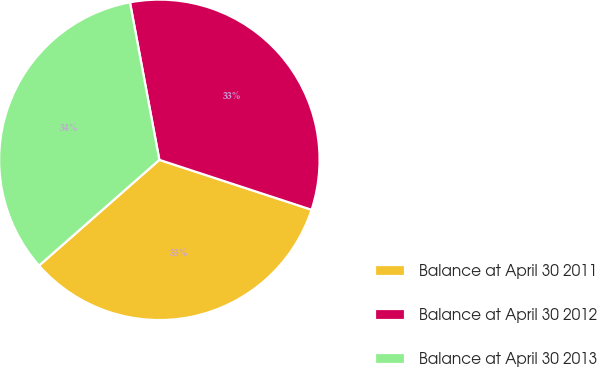<chart> <loc_0><loc_0><loc_500><loc_500><pie_chart><fcel>Balance at April 30 2011<fcel>Balance at April 30 2012<fcel>Balance at April 30 2013<nl><fcel>33.48%<fcel>32.98%<fcel>33.54%<nl></chart> 